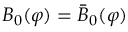<formula> <loc_0><loc_0><loc_500><loc_500>B _ { 0 } ( \varphi ) = \bar { B } _ { 0 } ( \varphi )</formula> 